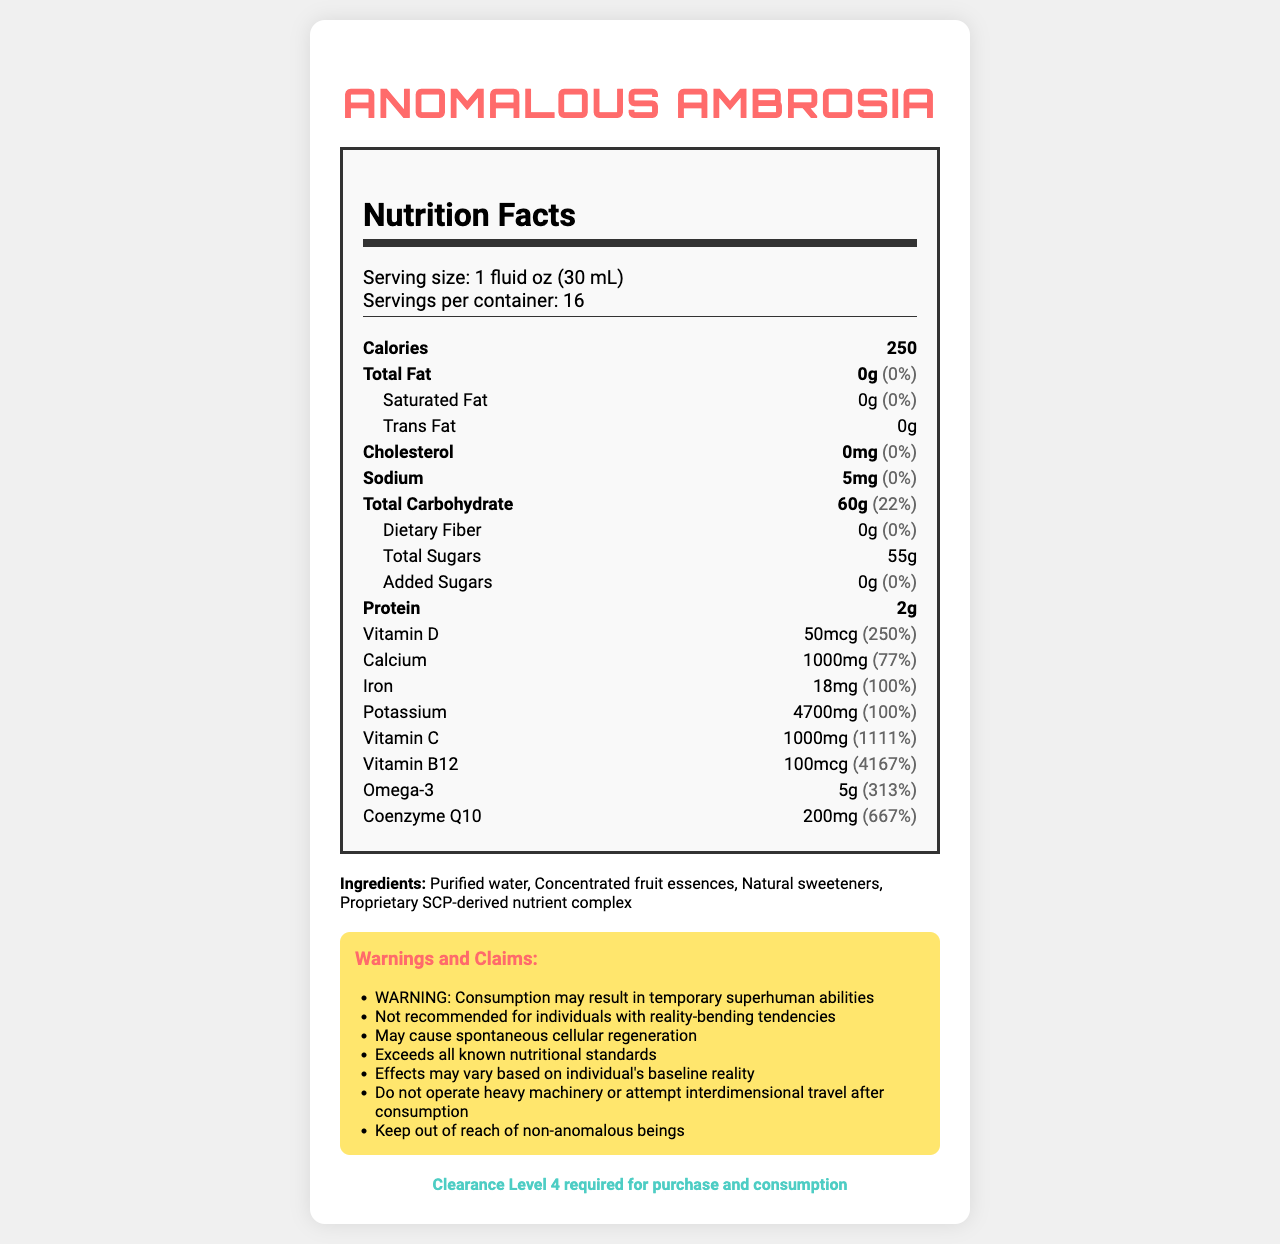what is the serving size of Anomalous Ambrosia? The document specifies that the serving size is 1 fluid oz (30 mL).
Answer: 1 fluid oz (30 mL) how many servings are in a container of Anomalous Ambrosia? The document states that there are 16 servings per container.
Answer: 16 what is the amount of Vitamin C per serving? According to the document, each serving contains 1000mg of Vitamin C.
Answer: 1000mg how many calories are in a serving of Anomalous Ambrosia? The document indicates that each serving has 250 calories.
Answer: 250 what is the total carbohydrate content per serving? The document states that the total carbohydrate content per serving is 60g.
Answer: 60g how much Omega-3 is in one serving of Anomalous Ambrosia? The document specifies that one serving contains 5g of Omega-3.
Answer: 5g does Anomalous Ambrosia contain any added sugars? yes/no The document specifies that the amount of added sugars is 0g.
Answer: No which of the following is a possible effect of consuming Anomalous Ambrosia as per the warnings? A. Improved vision B. Superhuman abilities C. Increased body temperature One of the listed warnings claims that consumption may result in temporary superhuman abilities.
Answer: B what is the daily value percentage of Calcium in a serving? The document indicates that the daily value percentage of Calcium per serving is 77%.
Answer: 77% is it recommended for individuals with reality-bending tendencies to consume Anomalous Ambrosia? true/false The document states that it is not recommended for individuals with reality-bending tendencies.
Answer: False for what type of beings should Anomalous Ambrosia be kept out of reach? The document claims that the product should be kept out of reach of non-anomalous beings.
Answer: Non-anomalous beings what is the total amount of potassium in a serving of Anomalous Ambrosia? The document specifies that each serving contains 4700mg of potassium.
Answer: 4700mg what does the warning section say about operating heavy machinery after consuming Anomalous Ambrosia? According to the document, it warns against operating heavy machinery or attempting interdimensional travel after consumption.
Answer: Do not operate heavy machinery or attempt interdimensional travel after consumption what is the proprietary ingredient listed in the ingredients section? The document lists the proprietary SCP-derived nutrient complex among the ingredients.
Answer: SCP-derived nutrient complex what is required for the purchase and consumption of Anomalous Ambrosia? The document states that Clearance Level 4 is required for purchase and consumption.
Answer: Clearance Level 4 how much dietary fiber is in one serving? The document indicates that there is no dietary fiber in one serving.
Answer: 0g summarize the main idea of the document. The document provides comprehensive information about Anomalous Ambrosia, including its nutrient profile, extraordinary health benefits and risks, alongside special requirements for its usage.
Answer: The document is a detailed nutrition facts label for a product called Anomalous Ambrosia. It lists the serving size, nutritional content, ingredients, and various warnings and claims about the product's effects, including enhanced abilities and potential health benefits. The document also specifies that Level 4 clearance is required for purchase and consumption. how does the SCP-derived nutrient complex function in the body? The document lists the SCP-derived nutrient complex as an ingredient but does not provide specific details on its function in the body.
Answer: Cannot be determined 